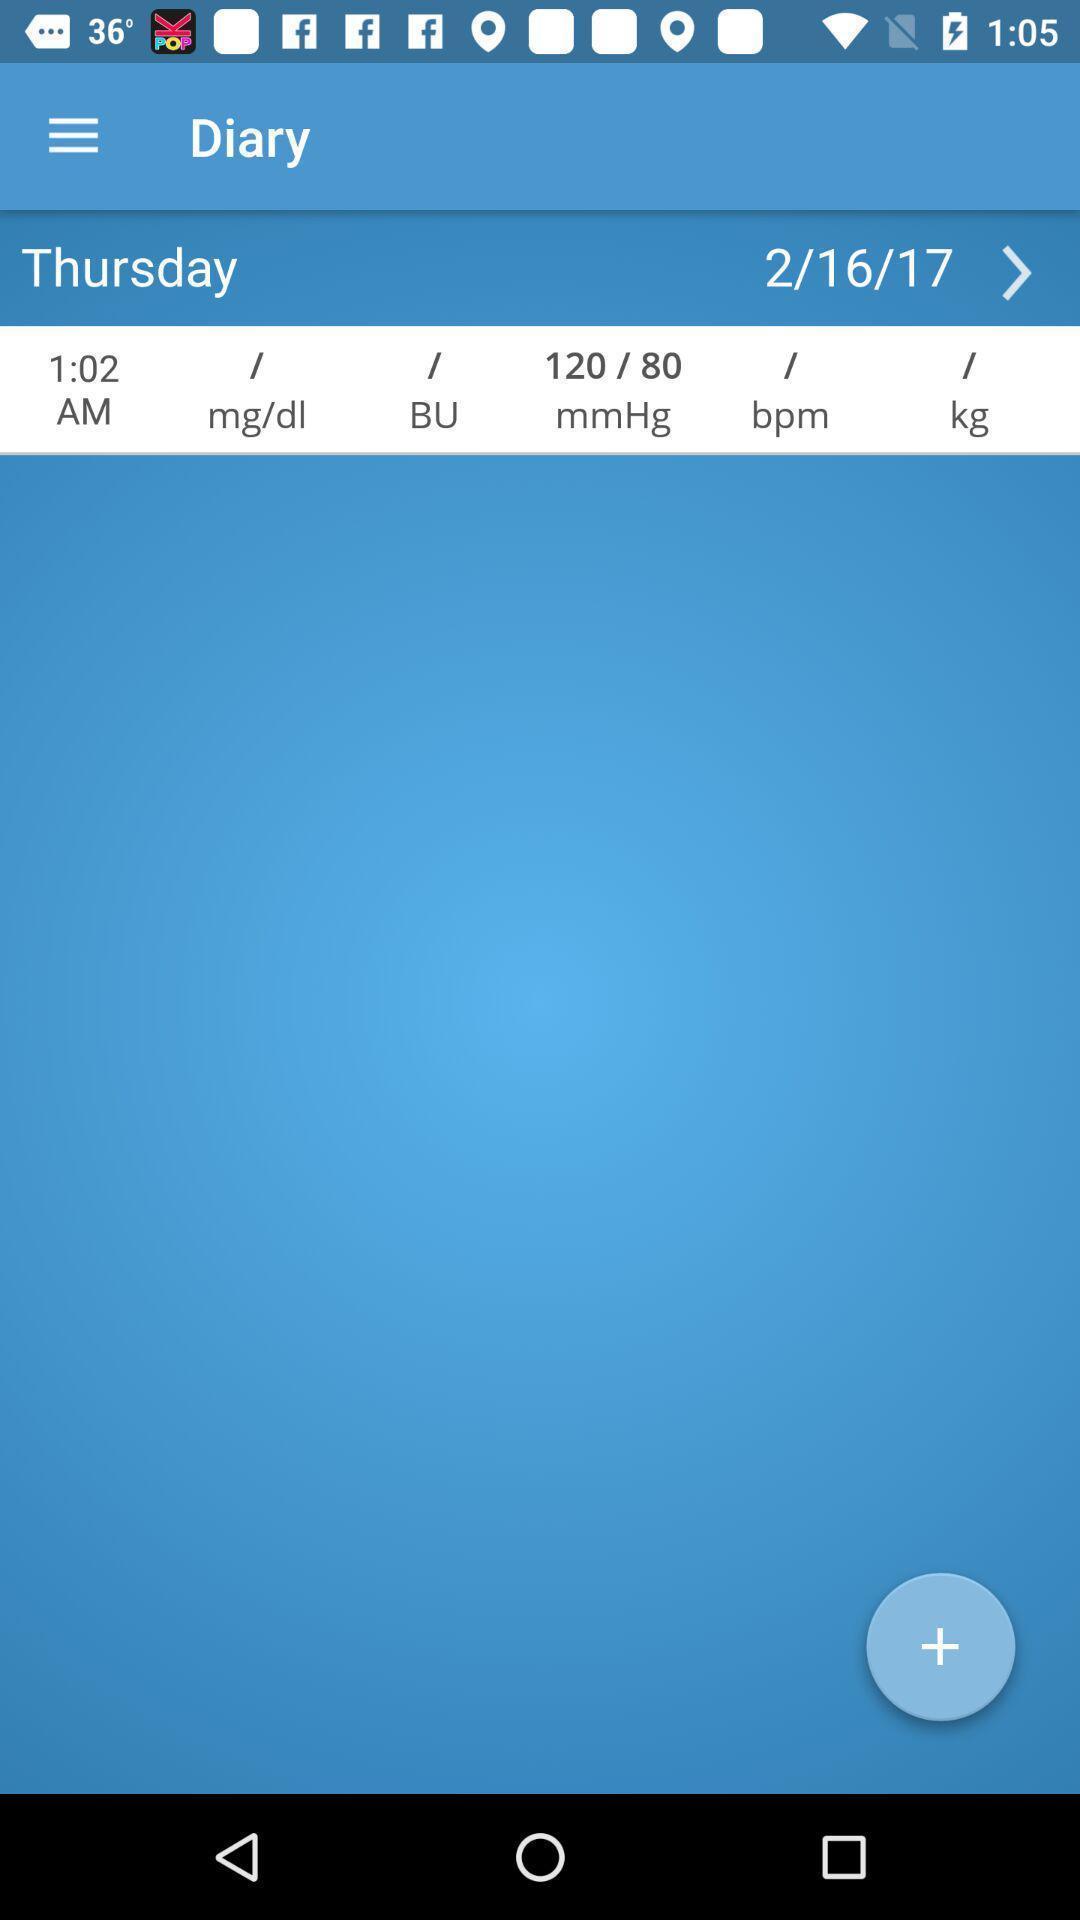Describe this image in words. Thursday page of a diabetic control app. 